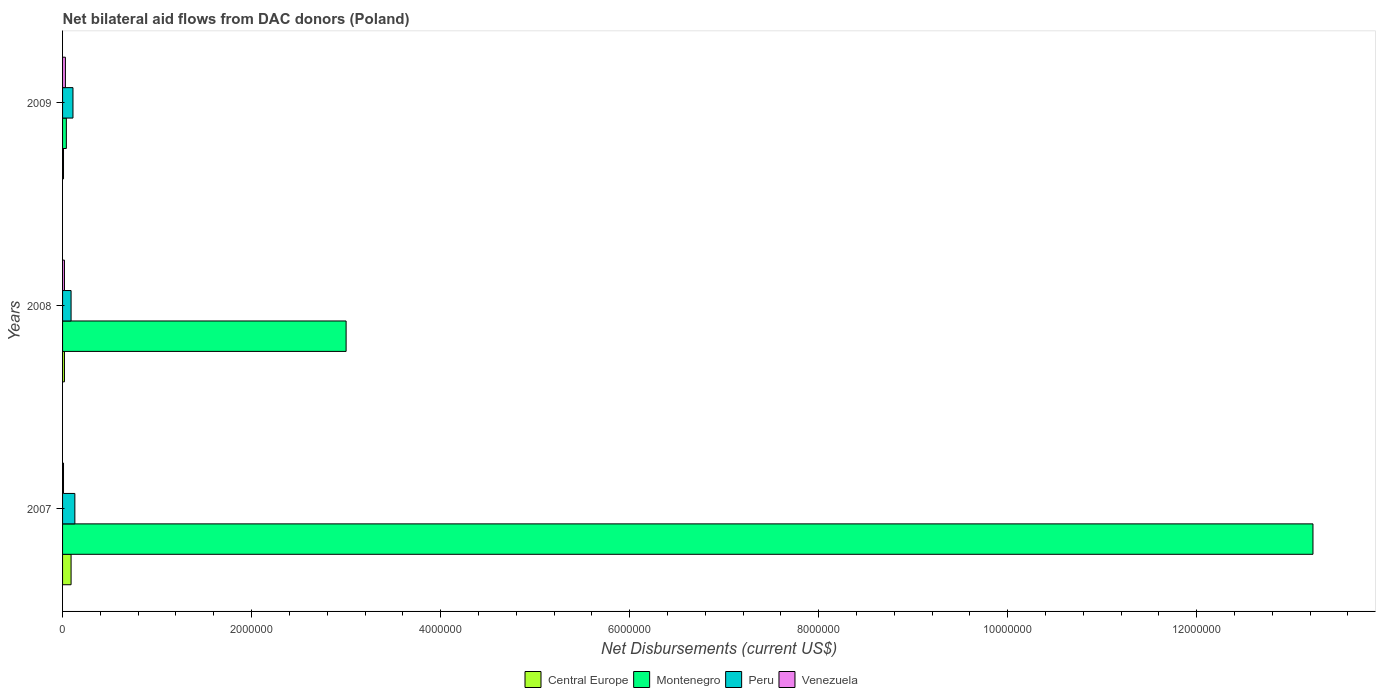What is the label of the 3rd group of bars from the top?
Offer a very short reply. 2007. What is the net bilateral aid flows in Venezuela in 2008?
Make the answer very short. 2.00e+04. In which year was the net bilateral aid flows in Central Europe maximum?
Keep it short and to the point. 2007. In which year was the net bilateral aid flows in Central Europe minimum?
Your answer should be very brief. 2009. What is the average net bilateral aid flows in Central Europe per year?
Your answer should be compact. 4.00e+04. What is the ratio of the net bilateral aid flows in Montenegro in 2007 to that in 2008?
Provide a succinct answer. 4.41. Is the difference between the net bilateral aid flows in Peru in 2007 and 2008 greater than the difference between the net bilateral aid flows in Montenegro in 2007 and 2008?
Offer a terse response. No. What is the difference between the highest and the second highest net bilateral aid flows in Peru?
Offer a very short reply. 2.00e+04. What is the difference between the highest and the lowest net bilateral aid flows in Montenegro?
Make the answer very short. 1.32e+07. Is the sum of the net bilateral aid flows in Montenegro in 2008 and 2009 greater than the maximum net bilateral aid flows in Central Europe across all years?
Provide a short and direct response. Yes. Is it the case that in every year, the sum of the net bilateral aid flows in Venezuela and net bilateral aid flows in Peru is greater than the sum of net bilateral aid flows in Central Europe and net bilateral aid flows in Montenegro?
Your response must be concise. No. What does the 2nd bar from the top in 2009 represents?
Make the answer very short. Peru. How many bars are there?
Provide a short and direct response. 12. What is the difference between two consecutive major ticks on the X-axis?
Keep it short and to the point. 2.00e+06. Are the values on the major ticks of X-axis written in scientific E-notation?
Your response must be concise. No. Where does the legend appear in the graph?
Your answer should be compact. Bottom center. What is the title of the graph?
Provide a short and direct response. Net bilateral aid flows from DAC donors (Poland). What is the label or title of the X-axis?
Offer a terse response. Net Disbursements (current US$). What is the label or title of the Y-axis?
Provide a succinct answer. Years. What is the Net Disbursements (current US$) in Central Europe in 2007?
Provide a succinct answer. 9.00e+04. What is the Net Disbursements (current US$) in Montenegro in 2007?
Give a very brief answer. 1.32e+07. What is the Net Disbursements (current US$) of Peru in 2007?
Provide a short and direct response. 1.30e+05. What is the Net Disbursements (current US$) of Central Europe in 2008?
Provide a short and direct response. 2.00e+04. What is the Net Disbursements (current US$) of Peru in 2008?
Your answer should be very brief. 9.00e+04. What is the Net Disbursements (current US$) in Venezuela in 2008?
Provide a succinct answer. 2.00e+04. What is the Net Disbursements (current US$) of Central Europe in 2009?
Provide a succinct answer. 10000. What is the Net Disbursements (current US$) of Montenegro in 2009?
Ensure brevity in your answer.  4.00e+04. What is the Net Disbursements (current US$) in Peru in 2009?
Offer a very short reply. 1.10e+05. What is the Net Disbursements (current US$) in Venezuela in 2009?
Keep it short and to the point. 3.00e+04. Across all years, what is the maximum Net Disbursements (current US$) in Montenegro?
Your response must be concise. 1.32e+07. Across all years, what is the maximum Net Disbursements (current US$) in Venezuela?
Your answer should be very brief. 3.00e+04. What is the total Net Disbursements (current US$) of Central Europe in the graph?
Your response must be concise. 1.20e+05. What is the total Net Disbursements (current US$) of Montenegro in the graph?
Your response must be concise. 1.63e+07. What is the total Net Disbursements (current US$) in Venezuela in the graph?
Your response must be concise. 6.00e+04. What is the difference between the Net Disbursements (current US$) in Central Europe in 2007 and that in 2008?
Keep it short and to the point. 7.00e+04. What is the difference between the Net Disbursements (current US$) of Montenegro in 2007 and that in 2008?
Give a very brief answer. 1.02e+07. What is the difference between the Net Disbursements (current US$) of Peru in 2007 and that in 2008?
Your response must be concise. 4.00e+04. What is the difference between the Net Disbursements (current US$) in Central Europe in 2007 and that in 2009?
Your response must be concise. 8.00e+04. What is the difference between the Net Disbursements (current US$) in Montenegro in 2007 and that in 2009?
Ensure brevity in your answer.  1.32e+07. What is the difference between the Net Disbursements (current US$) in Peru in 2007 and that in 2009?
Your answer should be compact. 2.00e+04. What is the difference between the Net Disbursements (current US$) in Montenegro in 2008 and that in 2009?
Your answer should be compact. 2.96e+06. What is the difference between the Net Disbursements (current US$) of Venezuela in 2008 and that in 2009?
Keep it short and to the point. -10000. What is the difference between the Net Disbursements (current US$) in Central Europe in 2007 and the Net Disbursements (current US$) in Montenegro in 2008?
Provide a succinct answer. -2.91e+06. What is the difference between the Net Disbursements (current US$) of Montenegro in 2007 and the Net Disbursements (current US$) of Peru in 2008?
Provide a short and direct response. 1.31e+07. What is the difference between the Net Disbursements (current US$) of Montenegro in 2007 and the Net Disbursements (current US$) of Venezuela in 2008?
Keep it short and to the point. 1.32e+07. What is the difference between the Net Disbursements (current US$) of Peru in 2007 and the Net Disbursements (current US$) of Venezuela in 2008?
Provide a short and direct response. 1.10e+05. What is the difference between the Net Disbursements (current US$) of Central Europe in 2007 and the Net Disbursements (current US$) of Montenegro in 2009?
Your answer should be very brief. 5.00e+04. What is the difference between the Net Disbursements (current US$) in Central Europe in 2007 and the Net Disbursements (current US$) in Peru in 2009?
Offer a terse response. -2.00e+04. What is the difference between the Net Disbursements (current US$) of Montenegro in 2007 and the Net Disbursements (current US$) of Peru in 2009?
Make the answer very short. 1.31e+07. What is the difference between the Net Disbursements (current US$) of Montenegro in 2007 and the Net Disbursements (current US$) of Venezuela in 2009?
Provide a short and direct response. 1.32e+07. What is the difference between the Net Disbursements (current US$) of Peru in 2007 and the Net Disbursements (current US$) of Venezuela in 2009?
Your response must be concise. 1.00e+05. What is the difference between the Net Disbursements (current US$) of Montenegro in 2008 and the Net Disbursements (current US$) of Peru in 2009?
Keep it short and to the point. 2.89e+06. What is the difference between the Net Disbursements (current US$) of Montenegro in 2008 and the Net Disbursements (current US$) of Venezuela in 2009?
Offer a terse response. 2.97e+06. What is the average Net Disbursements (current US$) in Montenegro per year?
Keep it short and to the point. 5.42e+06. What is the average Net Disbursements (current US$) of Venezuela per year?
Give a very brief answer. 2.00e+04. In the year 2007, what is the difference between the Net Disbursements (current US$) in Central Europe and Net Disbursements (current US$) in Montenegro?
Your response must be concise. -1.31e+07. In the year 2007, what is the difference between the Net Disbursements (current US$) in Central Europe and Net Disbursements (current US$) in Venezuela?
Ensure brevity in your answer.  8.00e+04. In the year 2007, what is the difference between the Net Disbursements (current US$) in Montenegro and Net Disbursements (current US$) in Peru?
Your answer should be very brief. 1.31e+07. In the year 2007, what is the difference between the Net Disbursements (current US$) of Montenegro and Net Disbursements (current US$) of Venezuela?
Your response must be concise. 1.32e+07. In the year 2007, what is the difference between the Net Disbursements (current US$) of Peru and Net Disbursements (current US$) of Venezuela?
Ensure brevity in your answer.  1.20e+05. In the year 2008, what is the difference between the Net Disbursements (current US$) in Central Europe and Net Disbursements (current US$) in Montenegro?
Offer a very short reply. -2.98e+06. In the year 2008, what is the difference between the Net Disbursements (current US$) of Central Europe and Net Disbursements (current US$) of Venezuela?
Offer a very short reply. 0. In the year 2008, what is the difference between the Net Disbursements (current US$) in Montenegro and Net Disbursements (current US$) in Peru?
Ensure brevity in your answer.  2.91e+06. In the year 2008, what is the difference between the Net Disbursements (current US$) in Montenegro and Net Disbursements (current US$) in Venezuela?
Offer a terse response. 2.98e+06. In the year 2008, what is the difference between the Net Disbursements (current US$) in Peru and Net Disbursements (current US$) in Venezuela?
Your answer should be very brief. 7.00e+04. In the year 2009, what is the difference between the Net Disbursements (current US$) in Central Europe and Net Disbursements (current US$) in Montenegro?
Keep it short and to the point. -3.00e+04. In the year 2009, what is the difference between the Net Disbursements (current US$) in Montenegro and Net Disbursements (current US$) in Peru?
Make the answer very short. -7.00e+04. In the year 2009, what is the difference between the Net Disbursements (current US$) of Peru and Net Disbursements (current US$) of Venezuela?
Your response must be concise. 8.00e+04. What is the ratio of the Net Disbursements (current US$) of Central Europe in 2007 to that in 2008?
Your answer should be very brief. 4.5. What is the ratio of the Net Disbursements (current US$) of Montenegro in 2007 to that in 2008?
Make the answer very short. 4.41. What is the ratio of the Net Disbursements (current US$) in Peru in 2007 to that in 2008?
Make the answer very short. 1.44. What is the ratio of the Net Disbursements (current US$) in Venezuela in 2007 to that in 2008?
Provide a short and direct response. 0.5. What is the ratio of the Net Disbursements (current US$) of Montenegro in 2007 to that in 2009?
Provide a short and direct response. 330.75. What is the ratio of the Net Disbursements (current US$) in Peru in 2007 to that in 2009?
Make the answer very short. 1.18. What is the ratio of the Net Disbursements (current US$) in Venezuela in 2007 to that in 2009?
Offer a terse response. 0.33. What is the ratio of the Net Disbursements (current US$) in Peru in 2008 to that in 2009?
Offer a terse response. 0.82. What is the difference between the highest and the second highest Net Disbursements (current US$) of Central Europe?
Make the answer very short. 7.00e+04. What is the difference between the highest and the second highest Net Disbursements (current US$) in Montenegro?
Your answer should be very brief. 1.02e+07. What is the difference between the highest and the second highest Net Disbursements (current US$) in Venezuela?
Keep it short and to the point. 10000. What is the difference between the highest and the lowest Net Disbursements (current US$) of Montenegro?
Offer a very short reply. 1.32e+07. What is the difference between the highest and the lowest Net Disbursements (current US$) in Venezuela?
Offer a very short reply. 2.00e+04. 